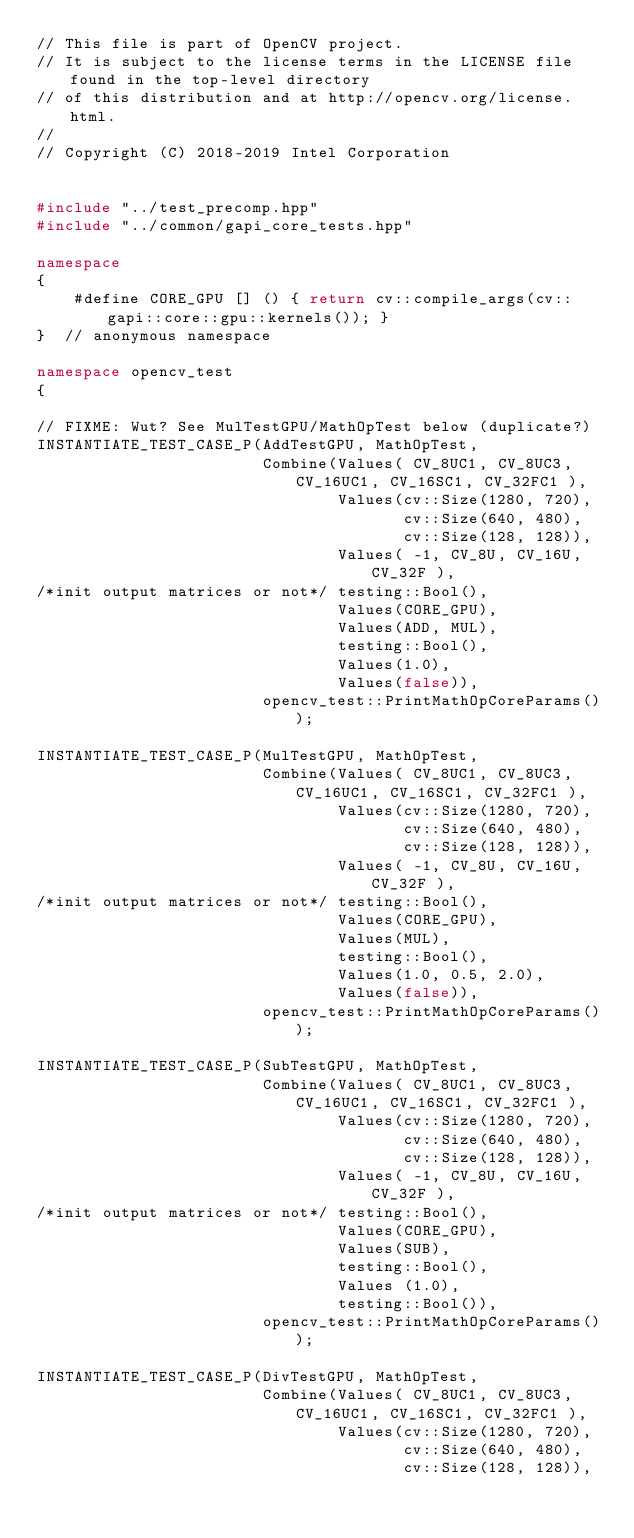<code> <loc_0><loc_0><loc_500><loc_500><_C++_>// This file is part of OpenCV project.
// It is subject to the license terms in the LICENSE file found in the top-level directory
// of this distribution and at http://opencv.org/license.html.
//
// Copyright (C) 2018-2019 Intel Corporation


#include "../test_precomp.hpp"
#include "../common/gapi_core_tests.hpp"

namespace
{
    #define CORE_GPU [] () { return cv::compile_args(cv::gapi::core::gpu::kernels()); }
}  // anonymous namespace

namespace opencv_test
{

// FIXME: Wut? See MulTestGPU/MathOpTest below (duplicate?)
INSTANTIATE_TEST_CASE_P(AddTestGPU, MathOpTest,
                        Combine(Values( CV_8UC1, CV_8UC3, CV_16UC1, CV_16SC1, CV_32FC1 ),
                                Values(cv::Size(1280, 720),
                                       cv::Size(640, 480),
                                       cv::Size(128, 128)),
                                Values( -1, CV_8U, CV_16U, CV_32F ),
/*init output matrices or not*/ testing::Bool(),
                                Values(CORE_GPU),
                                Values(ADD, MUL),
                                testing::Bool(),
                                Values(1.0),
                                Values(false)),
                        opencv_test::PrintMathOpCoreParams());

INSTANTIATE_TEST_CASE_P(MulTestGPU, MathOpTest,
                        Combine(Values( CV_8UC1, CV_8UC3, CV_16UC1, CV_16SC1, CV_32FC1 ),
                                Values(cv::Size(1280, 720),
                                       cv::Size(640, 480),
                                       cv::Size(128, 128)),
                                Values( -1, CV_8U, CV_16U, CV_32F ),
/*init output matrices or not*/ testing::Bool(),
                                Values(CORE_GPU),
                                Values(MUL),
                                testing::Bool(),
                                Values(1.0, 0.5, 2.0),
                                Values(false)),
                        opencv_test::PrintMathOpCoreParams());

INSTANTIATE_TEST_CASE_P(SubTestGPU, MathOpTest,
                        Combine(Values( CV_8UC1, CV_8UC3, CV_16UC1, CV_16SC1, CV_32FC1 ),
                                Values(cv::Size(1280, 720),
                                       cv::Size(640, 480),
                                       cv::Size(128, 128)),
                                Values( -1, CV_8U, CV_16U, CV_32F ),
/*init output matrices or not*/ testing::Bool(),
                                Values(CORE_GPU),
                                Values(SUB),
                                testing::Bool(),
                                Values (1.0),
                                testing::Bool()),
                        opencv_test::PrintMathOpCoreParams());

INSTANTIATE_TEST_CASE_P(DivTestGPU, MathOpTest,
                        Combine(Values( CV_8UC1, CV_8UC3, CV_16UC1, CV_16SC1, CV_32FC1 ),
                                Values(cv::Size(1280, 720),
                                       cv::Size(640, 480),
                                       cv::Size(128, 128)),</code> 